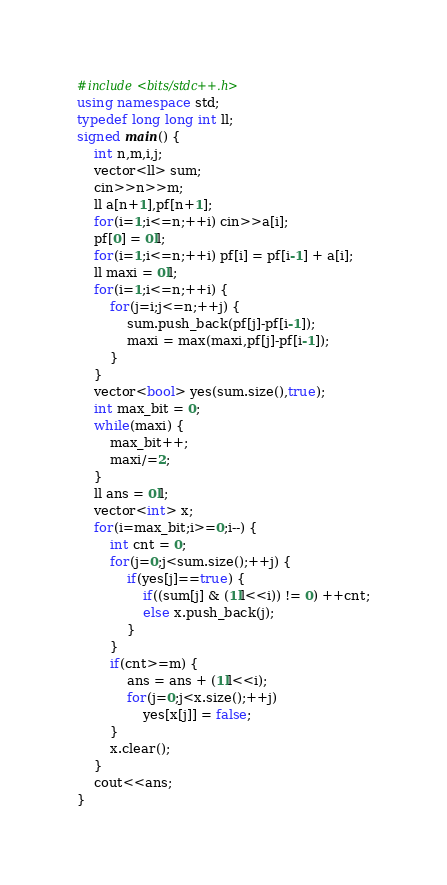Convert code to text. <code><loc_0><loc_0><loc_500><loc_500><_C++_>#include<bits/stdc++.h>
using namespace std;
typedef long long int ll;
signed main() {
	int n,m,i,j;
	vector<ll> sum;
	cin>>n>>m;
	ll a[n+1],pf[n+1];
	for(i=1;i<=n;++i) cin>>a[i];
	pf[0] = 0ll;
	for(i=1;i<=n;++i) pf[i] = pf[i-1] + a[i];
	ll maxi = 0ll;
	for(i=1;i<=n;++i) {
		for(j=i;j<=n;++j) {
			sum.push_back(pf[j]-pf[i-1]);
			maxi = max(maxi,pf[j]-pf[i-1]);
		}
	}
	vector<bool> yes(sum.size(),true);
	int max_bit = 0;
	while(maxi) {
		max_bit++;
		maxi/=2;
	}
	ll ans = 0ll;
	vector<int> x;
	for(i=max_bit;i>=0;i--) {
		int cnt = 0;
		for(j=0;j<sum.size();++j) {
			if(yes[j]==true) {
				if((sum[j] & (1ll<<i)) != 0) ++cnt;
				else x.push_back(j);
			}
		}
		if(cnt>=m) {
			ans = ans + (1ll<<i);
			for(j=0;j<x.size();++j)
				yes[x[j]] = false;
		}
		x.clear();
	}
	cout<<ans;
}</code> 